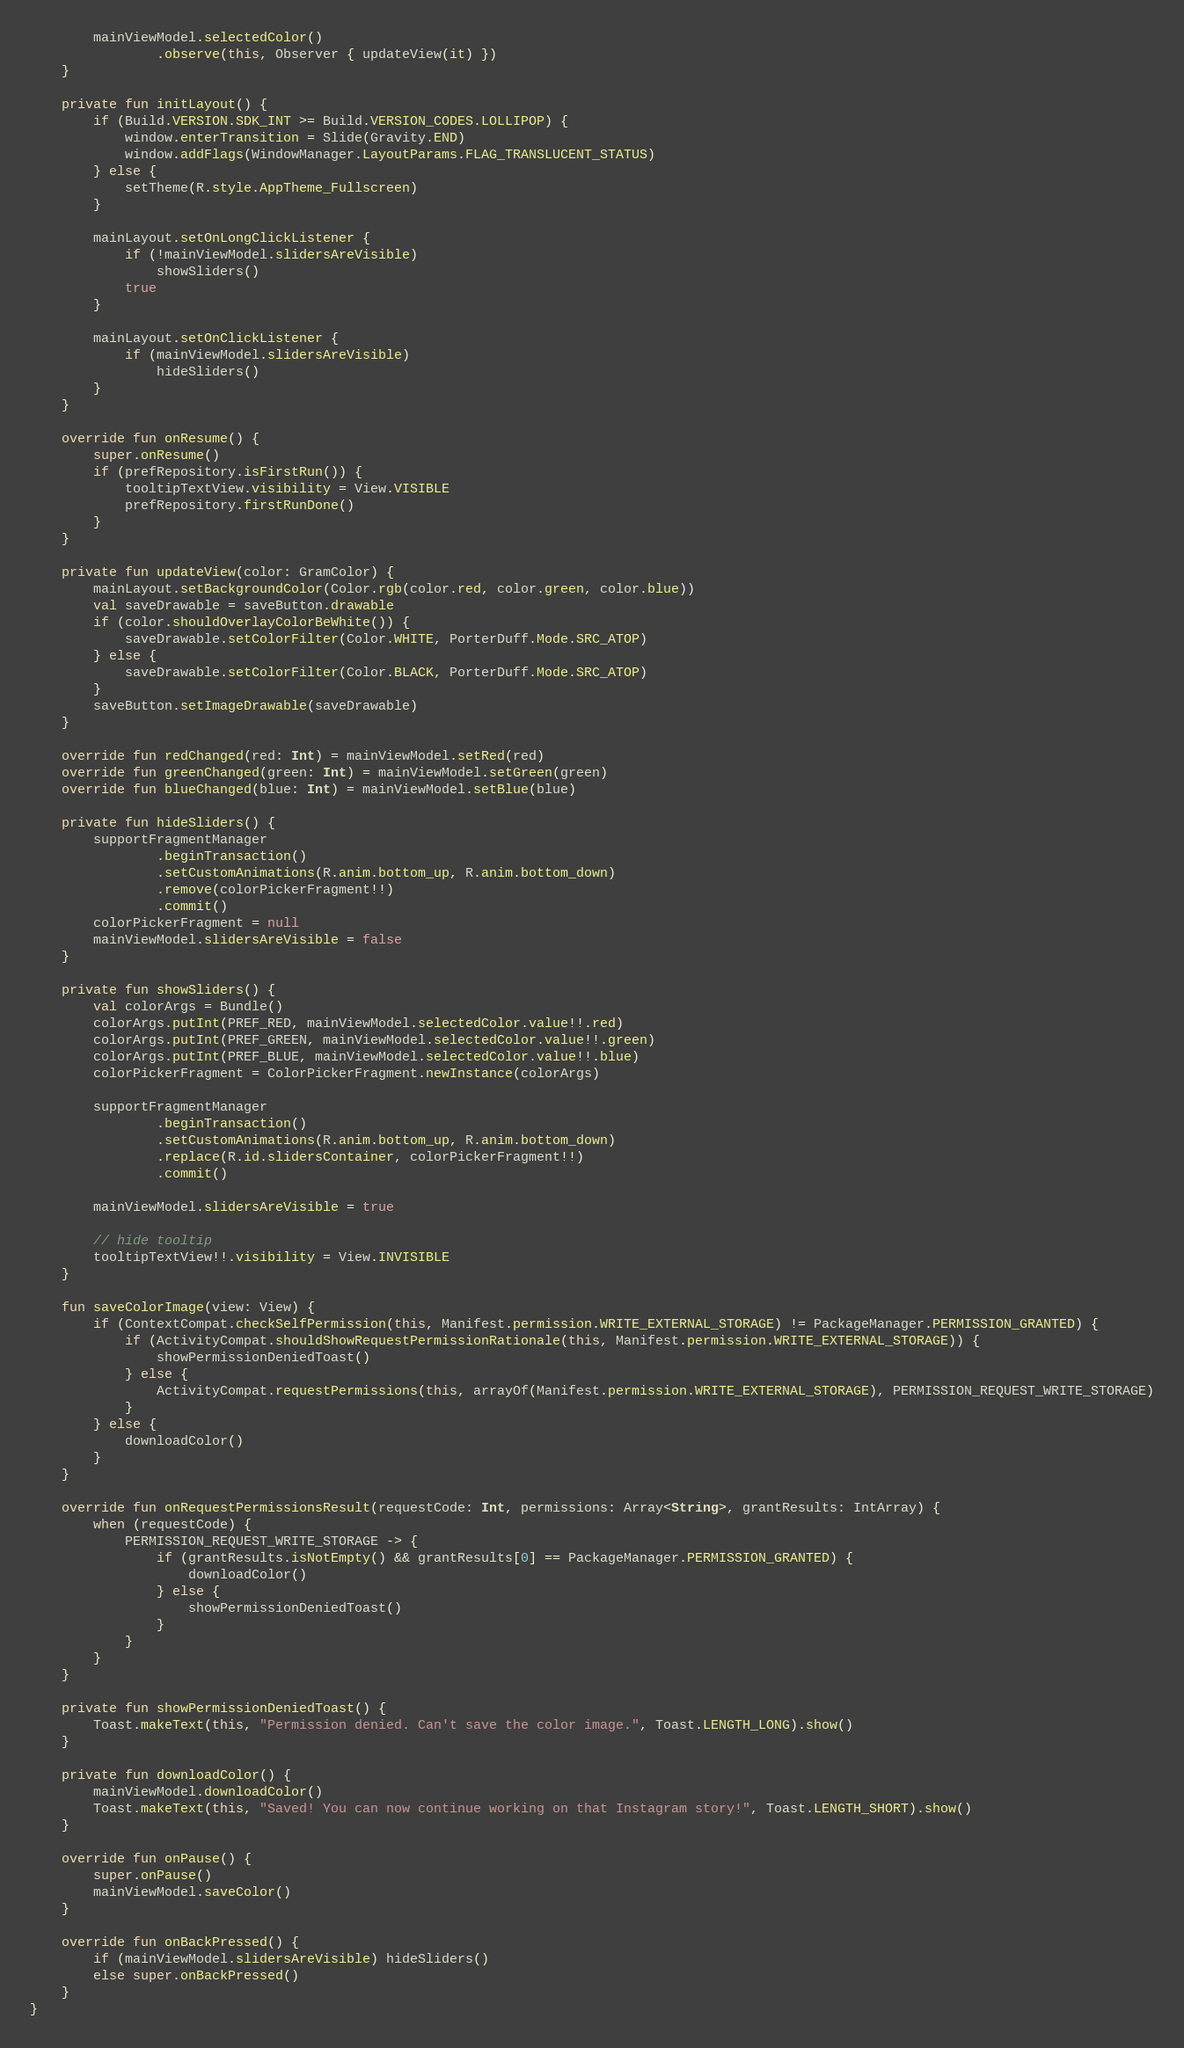<code> <loc_0><loc_0><loc_500><loc_500><_Kotlin_>        mainViewModel.selectedColor()
                .observe(this, Observer { updateView(it) })
    }

    private fun initLayout() {
        if (Build.VERSION.SDK_INT >= Build.VERSION_CODES.LOLLIPOP) {
            window.enterTransition = Slide(Gravity.END)
            window.addFlags(WindowManager.LayoutParams.FLAG_TRANSLUCENT_STATUS)
        } else {
            setTheme(R.style.AppTheme_Fullscreen)
        }

        mainLayout.setOnLongClickListener {
            if (!mainViewModel.slidersAreVisible)
                showSliders()
            true
        }

        mainLayout.setOnClickListener {
            if (mainViewModel.slidersAreVisible)
                hideSliders()
        }
    }

    override fun onResume() {
        super.onResume()
        if (prefRepository.isFirstRun()) {
            tooltipTextView.visibility = View.VISIBLE
            prefRepository.firstRunDone()
        }
    }

    private fun updateView(color: GramColor) {
        mainLayout.setBackgroundColor(Color.rgb(color.red, color.green, color.blue))
        val saveDrawable = saveButton.drawable
        if (color.shouldOverlayColorBeWhite()) {
            saveDrawable.setColorFilter(Color.WHITE, PorterDuff.Mode.SRC_ATOP)
        } else {
            saveDrawable.setColorFilter(Color.BLACK, PorterDuff.Mode.SRC_ATOP)
        }
        saveButton.setImageDrawable(saveDrawable)
    }

    override fun redChanged(red: Int) = mainViewModel.setRed(red)
    override fun greenChanged(green: Int) = mainViewModel.setGreen(green)
    override fun blueChanged(blue: Int) = mainViewModel.setBlue(blue)

    private fun hideSliders() {
        supportFragmentManager
                .beginTransaction()
                .setCustomAnimations(R.anim.bottom_up, R.anim.bottom_down)
                .remove(colorPickerFragment!!)
                .commit()
        colorPickerFragment = null
        mainViewModel.slidersAreVisible = false
    }

    private fun showSliders() {
        val colorArgs = Bundle()
        colorArgs.putInt(PREF_RED, mainViewModel.selectedColor.value!!.red)
        colorArgs.putInt(PREF_GREEN, mainViewModel.selectedColor.value!!.green)
        colorArgs.putInt(PREF_BLUE, mainViewModel.selectedColor.value!!.blue)
        colorPickerFragment = ColorPickerFragment.newInstance(colorArgs)

        supportFragmentManager
                .beginTransaction()
                .setCustomAnimations(R.anim.bottom_up, R.anim.bottom_down)
                .replace(R.id.slidersContainer, colorPickerFragment!!)
                .commit()

        mainViewModel.slidersAreVisible = true

        // hide tooltip
        tooltipTextView!!.visibility = View.INVISIBLE
    }

    fun saveColorImage(view: View) {
        if (ContextCompat.checkSelfPermission(this, Manifest.permission.WRITE_EXTERNAL_STORAGE) != PackageManager.PERMISSION_GRANTED) {
            if (ActivityCompat.shouldShowRequestPermissionRationale(this, Manifest.permission.WRITE_EXTERNAL_STORAGE)) {
                showPermissionDeniedToast()
            } else {
                ActivityCompat.requestPermissions(this, arrayOf(Manifest.permission.WRITE_EXTERNAL_STORAGE), PERMISSION_REQUEST_WRITE_STORAGE)
            }
        } else {
            downloadColor()
        }
    }

    override fun onRequestPermissionsResult(requestCode: Int, permissions: Array<String>, grantResults: IntArray) {
        when (requestCode) {
            PERMISSION_REQUEST_WRITE_STORAGE -> {
                if (grantResults.isNotEmpty() && grantResults[0] == PackageManager.PERMISSION_GRANTED) {
                    downloadColor()
                } else {
                    showPermissionDeniedToast()
                }
            }
        }
    }

    private fun showPermissionDeniedToast() {
        Toast.makeText(this, "Permission denied. Can't save the color image.", Toast.LENGTH_LONG).show()
    }

    private fun downloadColor() {
        mainViewModel.downloadColor()
        Toast.makeText(this, "Saved! You can now continue working on that Instagram story!", Toast.LENGTH_SHORT).show()
    }

    override fun onPause() {
        super.onPause()
        mainViewModel.saveColor()
    }

    override fun onBackPressed() {
        if (mainViewModel.slidersAreVisible) hideSliders()
        else super.onBackPressed()
    }
}
</code> 